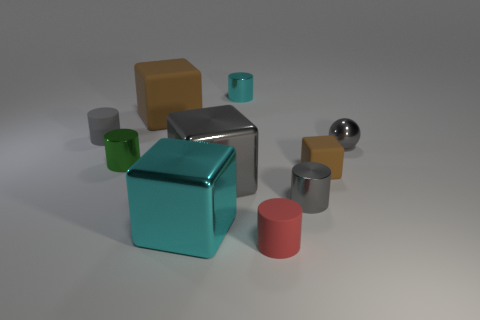Can you tell me what material the objects might be made of? The objects in the image seem to have various finishes indicative of different materials. The metallic sheen on some suggests they might be made of metal. The objects with matte finishes could be composed of plastic or a painted surface. 